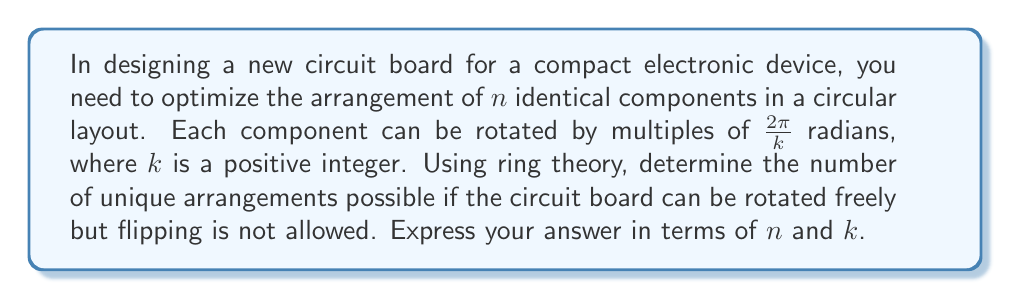Can you solve this math problem? To solve this problem, we can apply concepts from ring theory, particularly the orbit-stabilizer theorem and Burnside's lemma.

1) First, we need to identify the group acting on our set of arrangements. In this case, it's the cyclic group $C_n$ of rotations of the circuit board.

2) The total number of configurations without considering symmetry is $k^n$, as each of the $n$ components can be in $k$ possible orientations.

3) We'll use Burnside's lemma, which states that the number of orbits $|X/G|$ is equal to the average number of elements fixed by each group element:

   $$|X/G| = \frac{1}{|G|} \sum_{g \in G} |X^g|$$

   where $X^g$ is the set of elements fixed by $g$.

4) For a rotation by $d$ positions (where $0 \leq d < n$), a configuration is fixed if and only if it repeats every $\gcd(n,d)$ components. This means there are $k^{\gcd(n,d)}$ configurations fixed by this rotation.

5) Therefore, we can express the number of unique arrangements as:

   $$\frac{1}{n} \sum_{d=0}^{n-1} k^{\gcd(n,d)}$$

6) This sum can be simplified using the properties of the Euler totient function $\phi(n)$. For each divisor $d$ of $n$, there are exactly $\phi(n/d)$ values of $i$ between $0$ and $n-1$ such that $\gcd(n,i) = d$.

7) Thus, we can rewrite our sum as:

   $$\frac{1}{n} \sum_{d|n} \phi(n/d) \cdot k^d$$

This final expression gives the number of unique arrangements in terms of $n$ and $k$.
Answer: The number of unique arrangements is:

$$\frac{1}{n} \sum_{d|n} \phi(n/d) \cdot k^d$$

where $\phi$ is the Euler totient function, and the sum is taken over all divisors $d$ of $n$. 